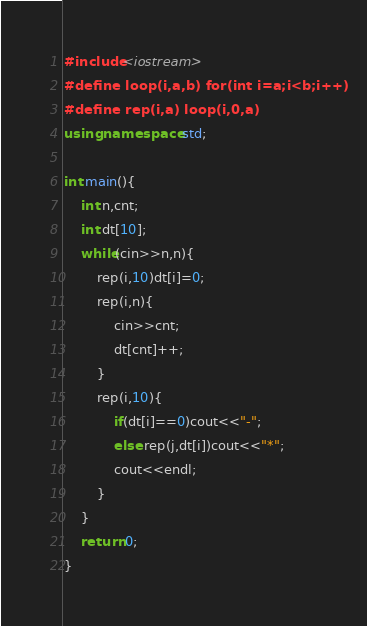Convert code to text. <code><loc_0><loc_0><loc_500><loc_500><_C++_>#include<iostream>
#define loop(i,a,b) for(int i=a;i<b;i++)
#define rep(i,a) loop(i,0,a)
using namespace std;

int main(){
	int n,cnt;
	int dt[10];
	while(cin>>n,n){
		rep(i,10)dt[i]=0;
		rep(i,n){
			cin>>cnt;
			dt[cnt]++;
		}
		rep(i,10){
			if(dt[i]==0)cout<<"-";
			else rep(j,dt[i])cout<<"*";
			cout<<endl;
		}
	}
	return 0;
}</code> 